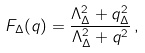Convert formula to latex. <formula><loc_0><loc_0><loc_500><loc_500>F _ { \Delta } ( q ) = \frac { \Lambda ^ { 2 } _ { \Delta } + q ^ { 2 } _ { \Delta } } { \Lambda ^ { 2 } _ { \Delta } + q ^ { 2 } } \, ,</formula> 